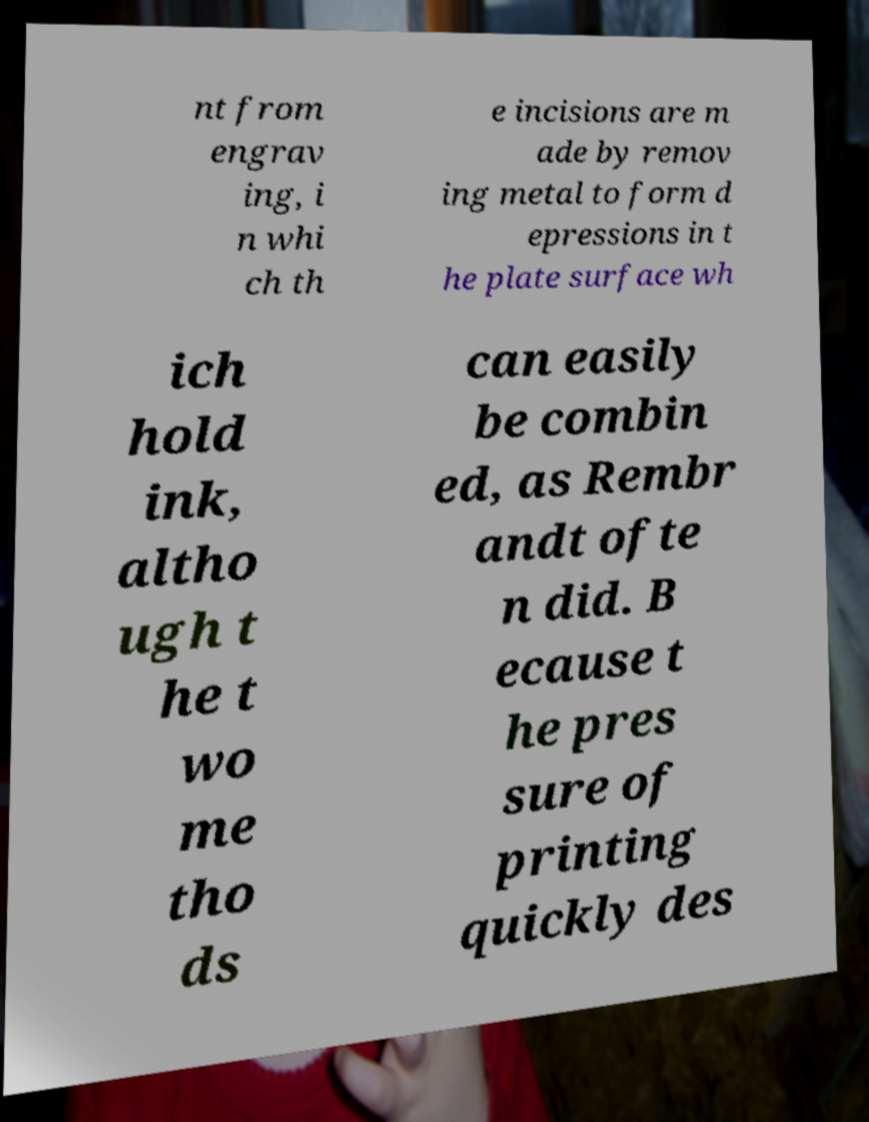For documentation purposes, I need the text within this image transcribed. Could you provide that? nt from engrav ing, i n whi ch th e incisions are m ade by remov ing metal to form d epressions in t he plate surface wh ich hold ink, altho ugh t he t wo me tho ds can easily be combin ed, as Rembr andt ofte n did. B ecause t he pres sure of printing quickly des 